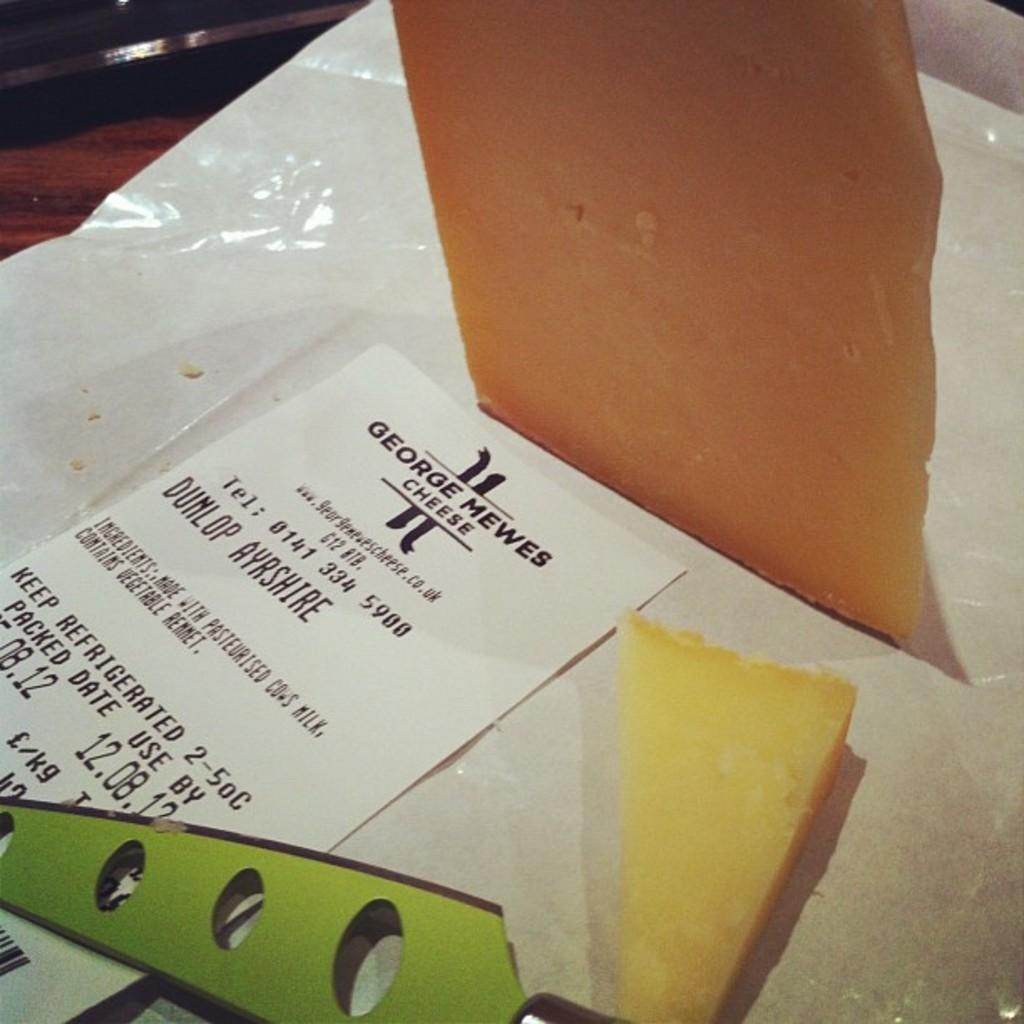Could you give a brief overview of what you see in this image? Here I can see few cheese pieces which are placed on a white color paper. Along with these I can see a white color paper on which I can see some text. At the top I can see the table. 